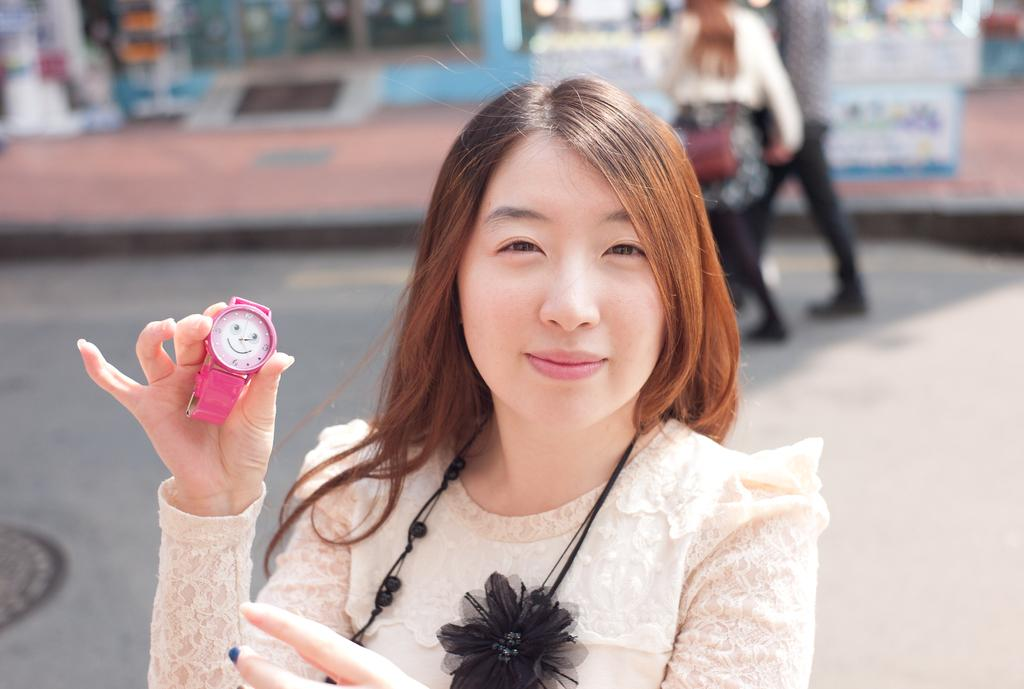Who is present in the image? There is a woman in the image. What is the woman doing in the image? The woman is smiling in the image. What object is the woman holding? The woman is holding a wrist watch in the image. Who else is present in the image? There is a couple in the image. What are the couple doing in the image? The couple is walking on a road in the image. What type of hot bun is the woman eating in the image? There is no hot bun present in the image; the woman is holding a wrist watch. Is the tank visible in the image? There is no tank present in the image. 